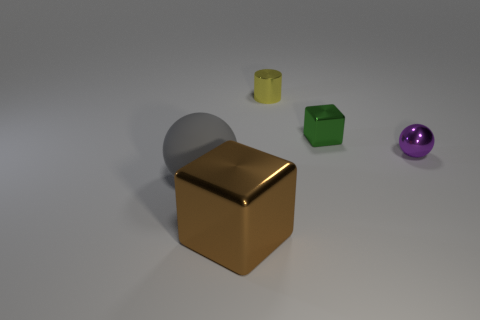Can you describe the overall composition and the materials of the objects seen in the picture? Certainly! The image presents a simple yet aesthetically pleasing arrangement of geometric objects against a neutral-toned background. On the left, there's a big matte gray sphere. The central figure is a large, glossy gold cube, which gleams with reflected light, indicating a metallic texture. To the right, we have a smaller matte green cube and a small glossy yellow cylinder. Finally, there's a shiny purple sphere to the left side of the scene. The objects appear to be made from various materials, including matte and glossy finishes, suggesting rubber or plastic-like substances and a metallic-like appearance for the gold cube. 